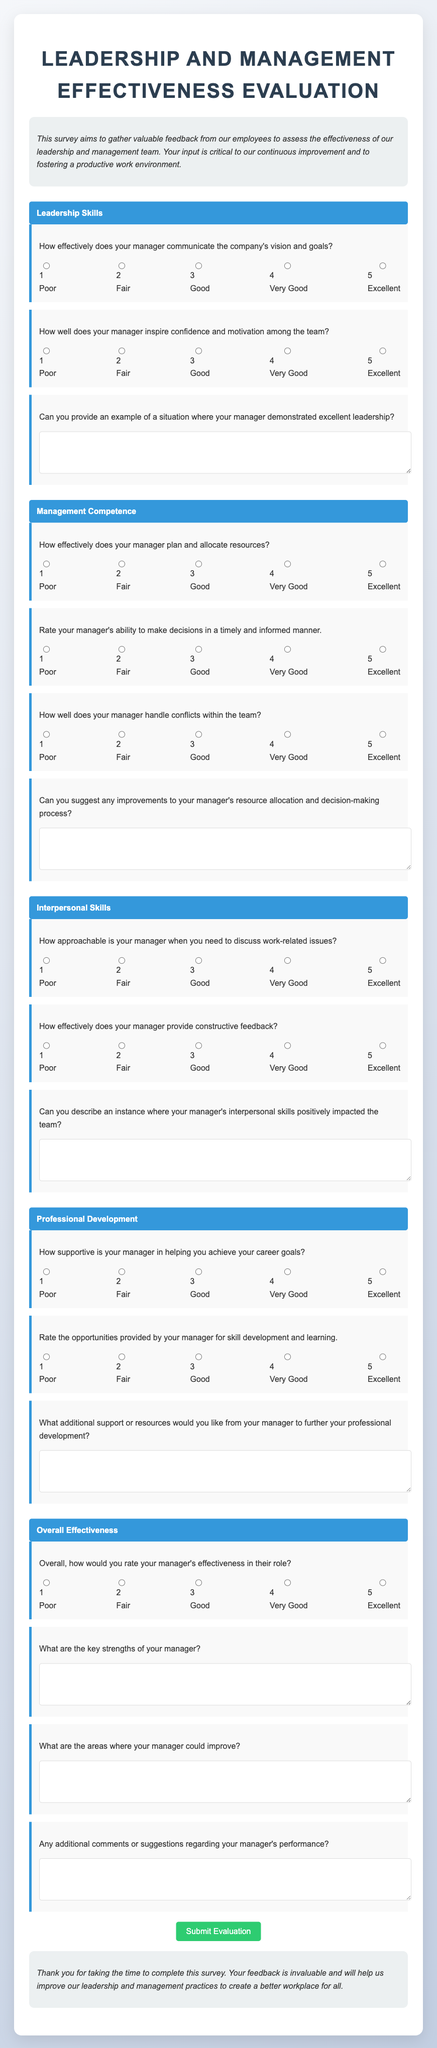How many categories are there in the survey? The survey is divided into four categories: Leadership Skills, Management Competence, Interpersonal Skills, and Professional Development.
Answer: 4 What is the highest rating option available for each question? The highest rating option available for each question is Excellent, which is represented by the number 5.
Answer: 5 What does the introductory paragraph emphasize? The introductory paragraph emphasizes gathering valuable feedback to assess the effectiveness of the leadership and management team for continuous improvement.
Answer: Valuable feedback How many questions are specifically about interpersonal skills? There are three questions specifically about interpersonal skills in the survey.
Answer: 3 What is the purpose of the open-ended questions in the survey? The purpose of the open-ended questions is to gather qualitative feedback and suggestions for improvement regarding the manager's performance and support provided.
Answer: Suggestions for improvement 